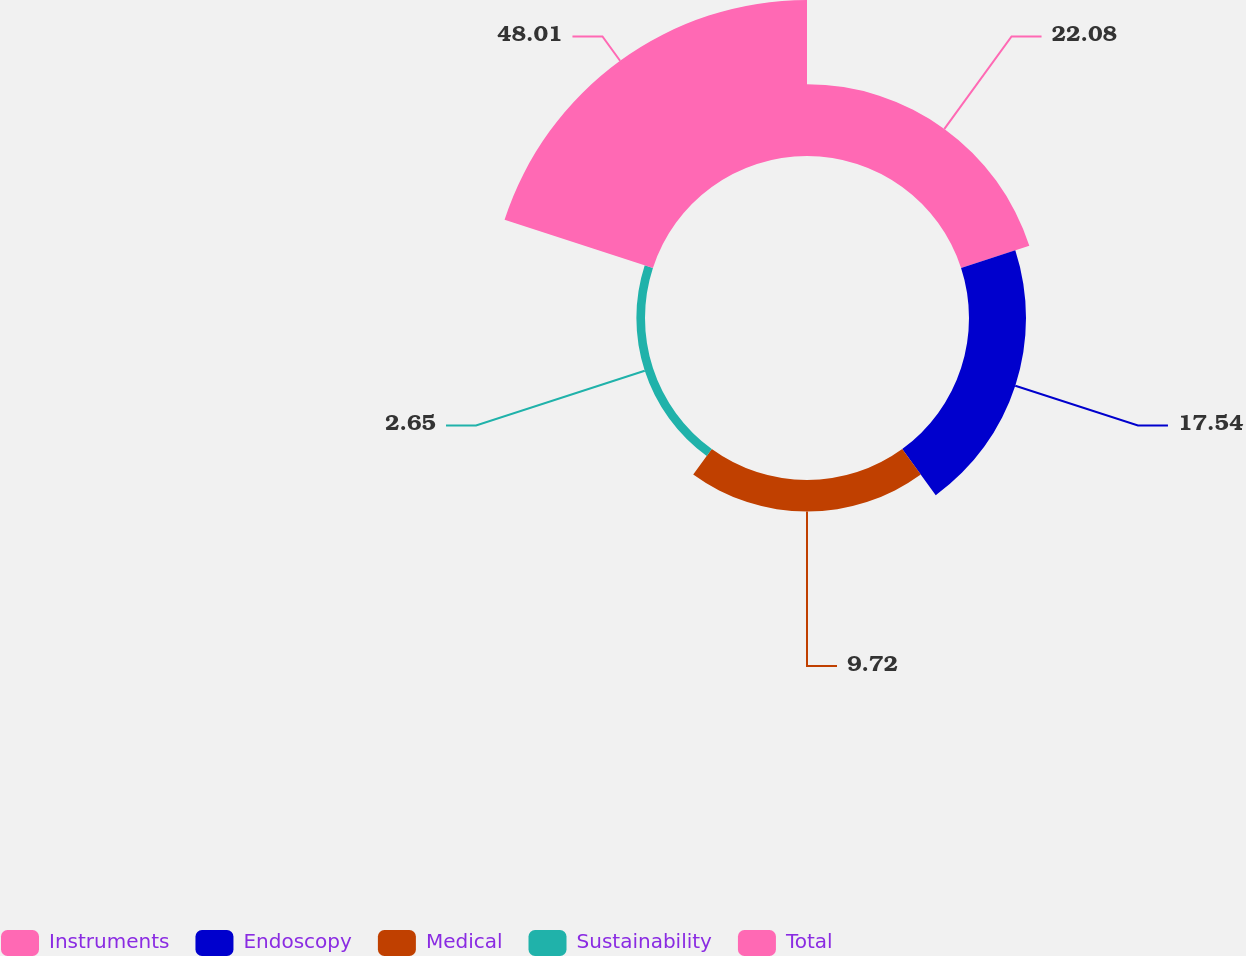Convert chart to OTSL. <chart><loc_0><loc_0><loc_500><loc_500><pie_chart><fcel>Instruments<fcel>Endoscopy<fcel>Medical<fcel>Sustainability<fcel>Total<nl><fcel>22.08%<fcel>17.54%<fcel>9.72%<fcel>2.65%<fcel>48.0%<nl></chart> 